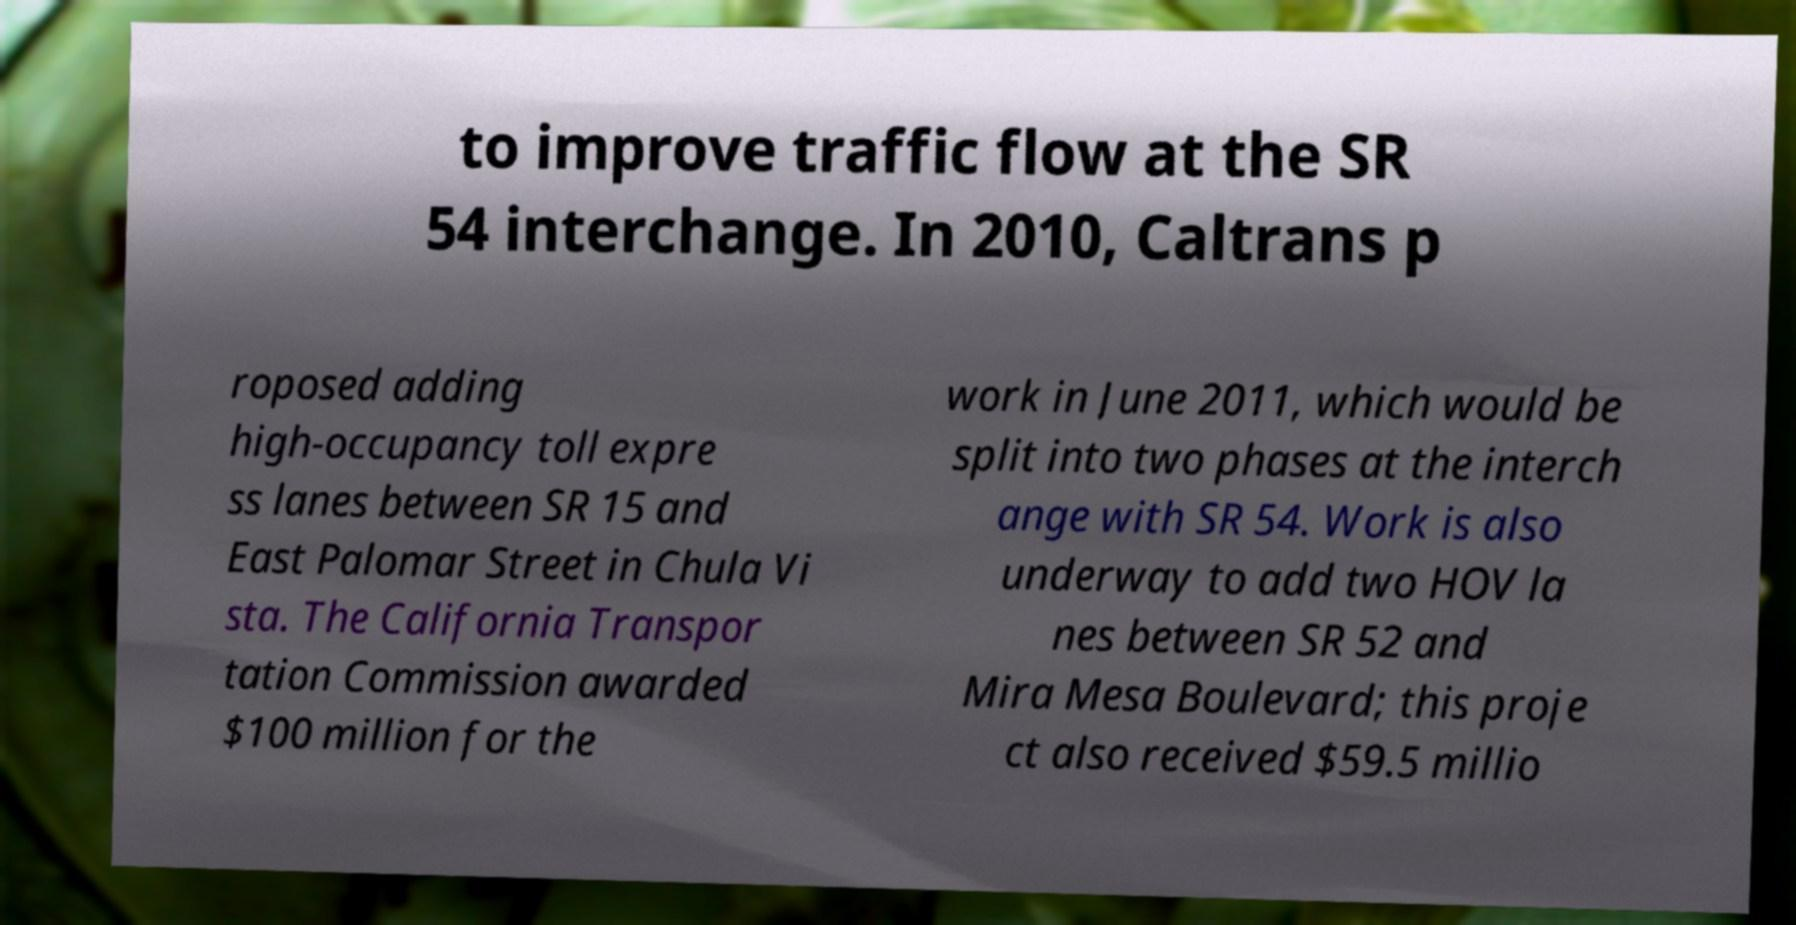I need the written content from this picture converted into text. Can you do that? to improve traffic flow at the SR 54 interchange. In 2010, Caltrans p roposed adding high-occupancy toll expre ss lanes between SR 15 and East Palomar Street in Chula Vi sta. The California Transpor tation Commission awarded $100 million for the work in June 2011, which would be split into two phases at the interch ange with SR 54. Work is also underway to add two HOV la nes between SR 52 and Mira Mesa Boulevard; this proje ct also received $59.5 millio 